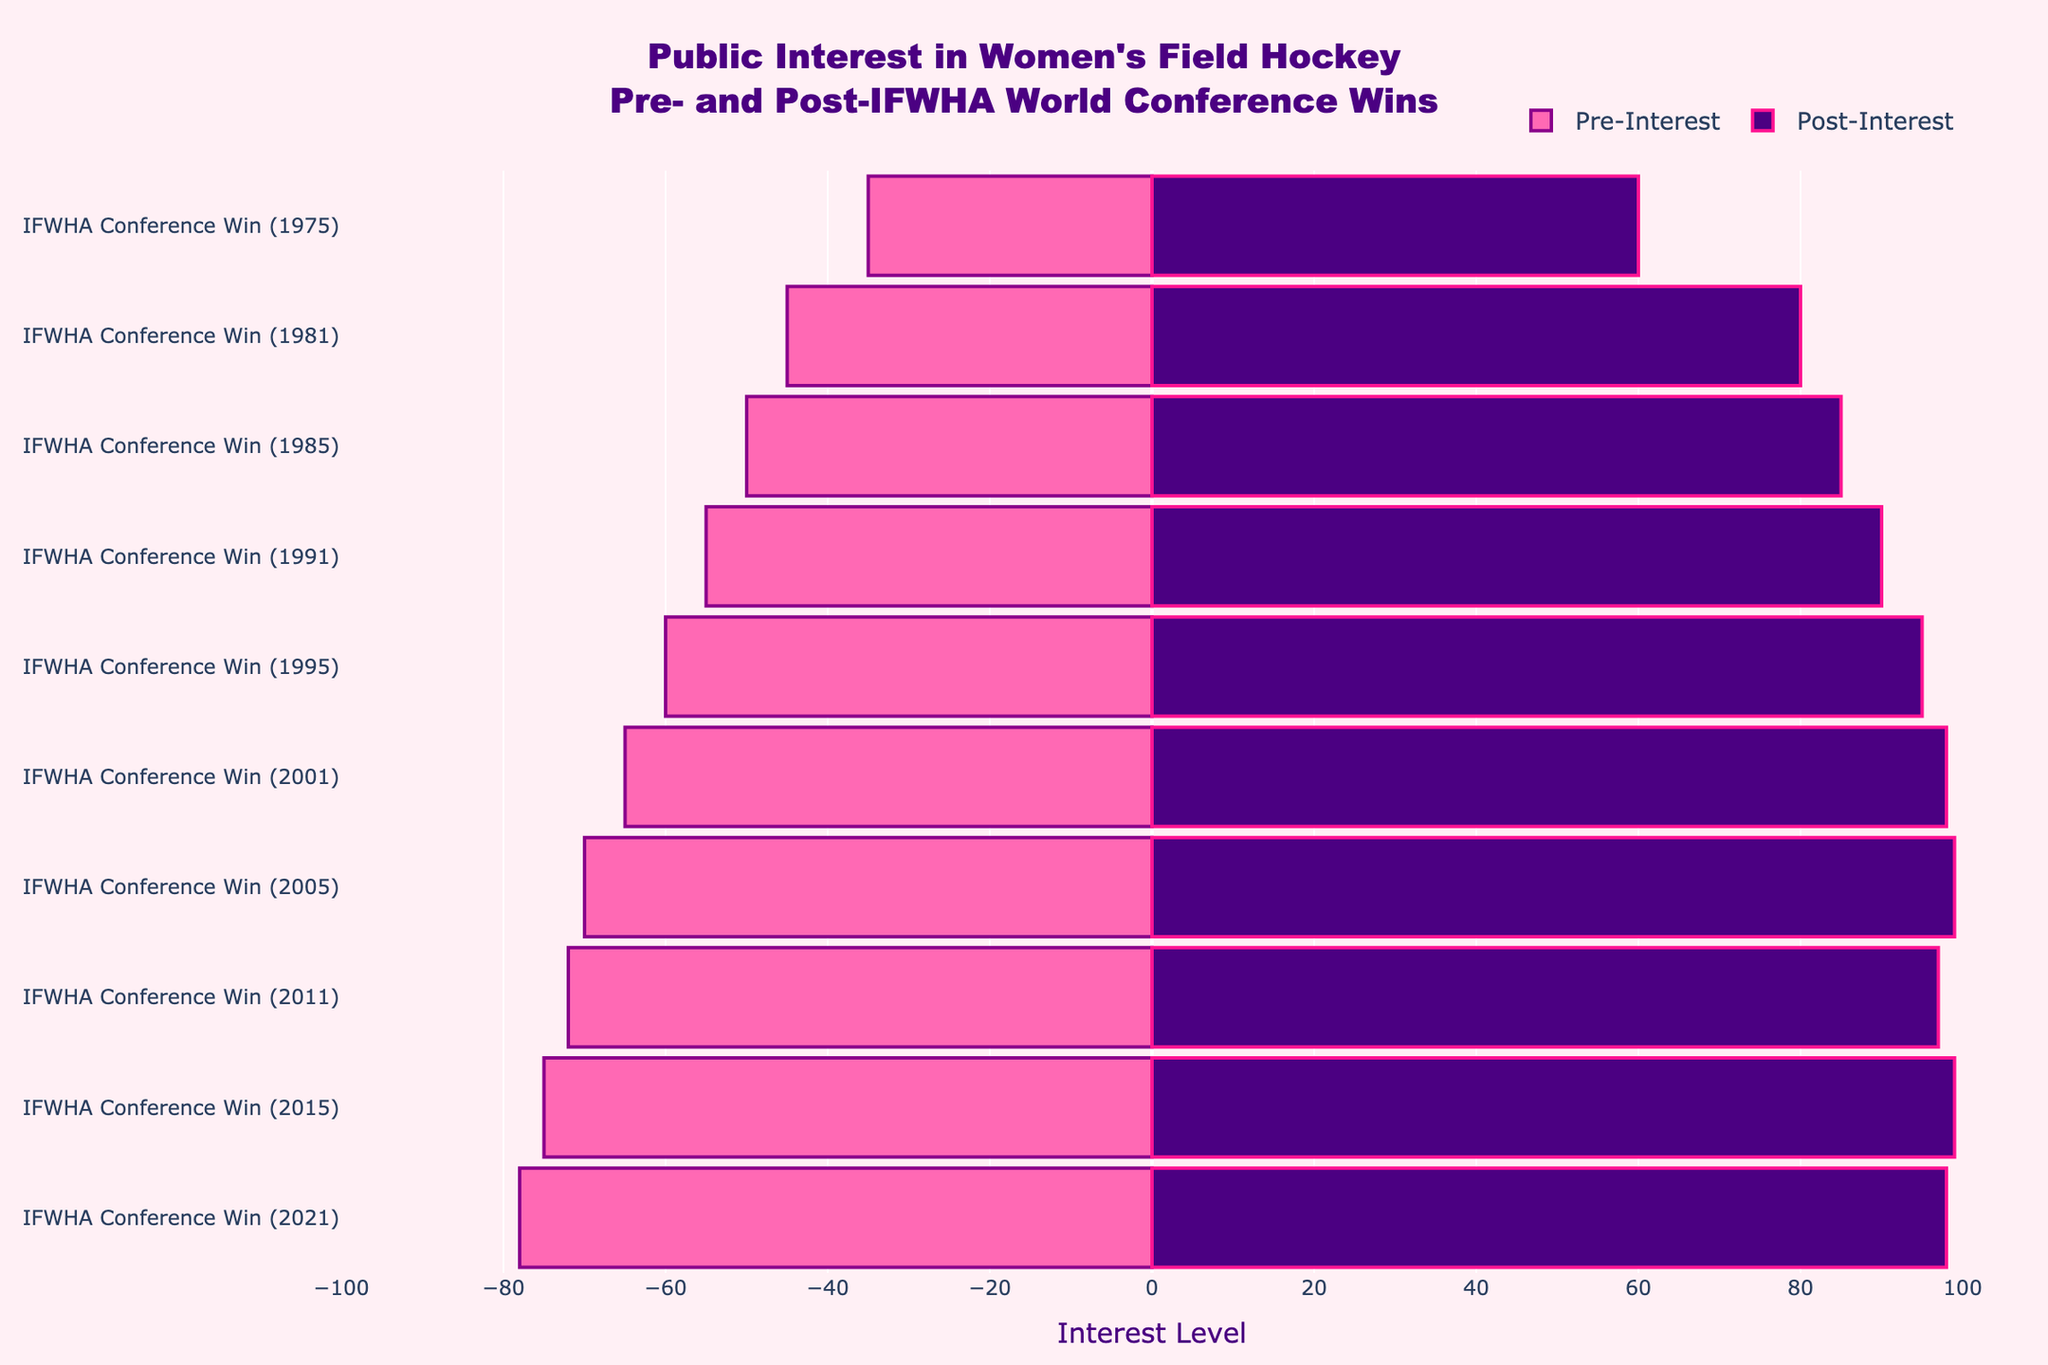What decade saw the highest increase in public interest post-IFWHA World Conference win? By comparing the difference between Pre-Interest and Post-Interest values for each decade, the 1980s had the highest increase. From 45 to 85 and 50 to 90 indicates an increase of 40 each, which is significantly higher than any other decades.
Answer: 1980s Compare the Pre-Interest level of the 1970s with the Post-Interest level of the 2020s. Which is higher? By observing the bar lengths, the 1970s have a Pre-Interest level of 35, while the 2020s have a Post-Interest level of 98. Clearly, 98 is higher than 35.
Answer: Post-Interest level of the 2020s Which event had the lowest Post-Interest value? By examining the Post-Interest bars' lengths, the 1975 IFWHA Conference Win had the shortest bar with a Post-Interest value of 60.
Answer: IFWHA Conference Win (1975) What is the sum of Pre-Interest for the 1980s? The Pre-Interest values for the 1980s are 45 and 50. Their sum is calculated by adding these two values together: 45 + 50 = 95.
Answer: 95 Which decade shows consistent growth in public interest pre- and post-IFWHA World Conference wins? Analyzing the trend per decade, from the 1990s to the 2020s, every subsequent event shows an increase in both Pre-Interest and Post-Interest levels. Hence, this period shows consistent growth.
Answer: 1990s to 2020s For the event IFWHA Conference Win (1981), what is the difference between Pre-Interest and Post-Interest levels? Viewing the bar lengths, the Pre-Interest level is 45 and the Post-Interest level is 80 for this event. The difference between these values is 80 - 45 = 35.
Answer: 35 How much did public interest change after the 2005 IFWHA Conference win? The Pre-Interest level for 2005 was 70 and the Post-Interest level was 99. The change is calculated as 99 - 70 = 29.
Answer: 29 Which event in the dataset shows the highest recorded Post-Interest level? By looking at the heights of the bars on the right, the 2015 IFWHA Conference Win has the highest recorded Post-Interest with a value of 99.
Answer: IFWHA Conference Win (2015) Considering the events of the 2010s, what is the average Pre-Interest value? The Pre-Interest values for the 2010s are 72 and 75. The average is calculated by (72 + 75) / 2 = 73.5.
Answer: 73.5 How does the Post-Interest for the 1991 event compare to the Pre-Interest for the 2001 event? The Post-Interest level for 1991 is 90 while the Pre-Interest level for 2001 is 65. Comparing 90 to 65, 90 is greater.
Answer: Post-Interest for 1991 is greater 